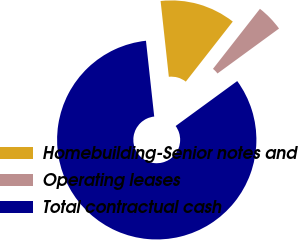Convert chart to OTSL. <chart><loc_0><loc_0><loc_500><loc_500><pie_chart><fcel>Homebuilding-Senior notes and<fcel>Operating leases<fcel>Total contractual cash<nl><fcel>12.29%<fcel>4.4%<fcel>83.32%<nl></chart> 